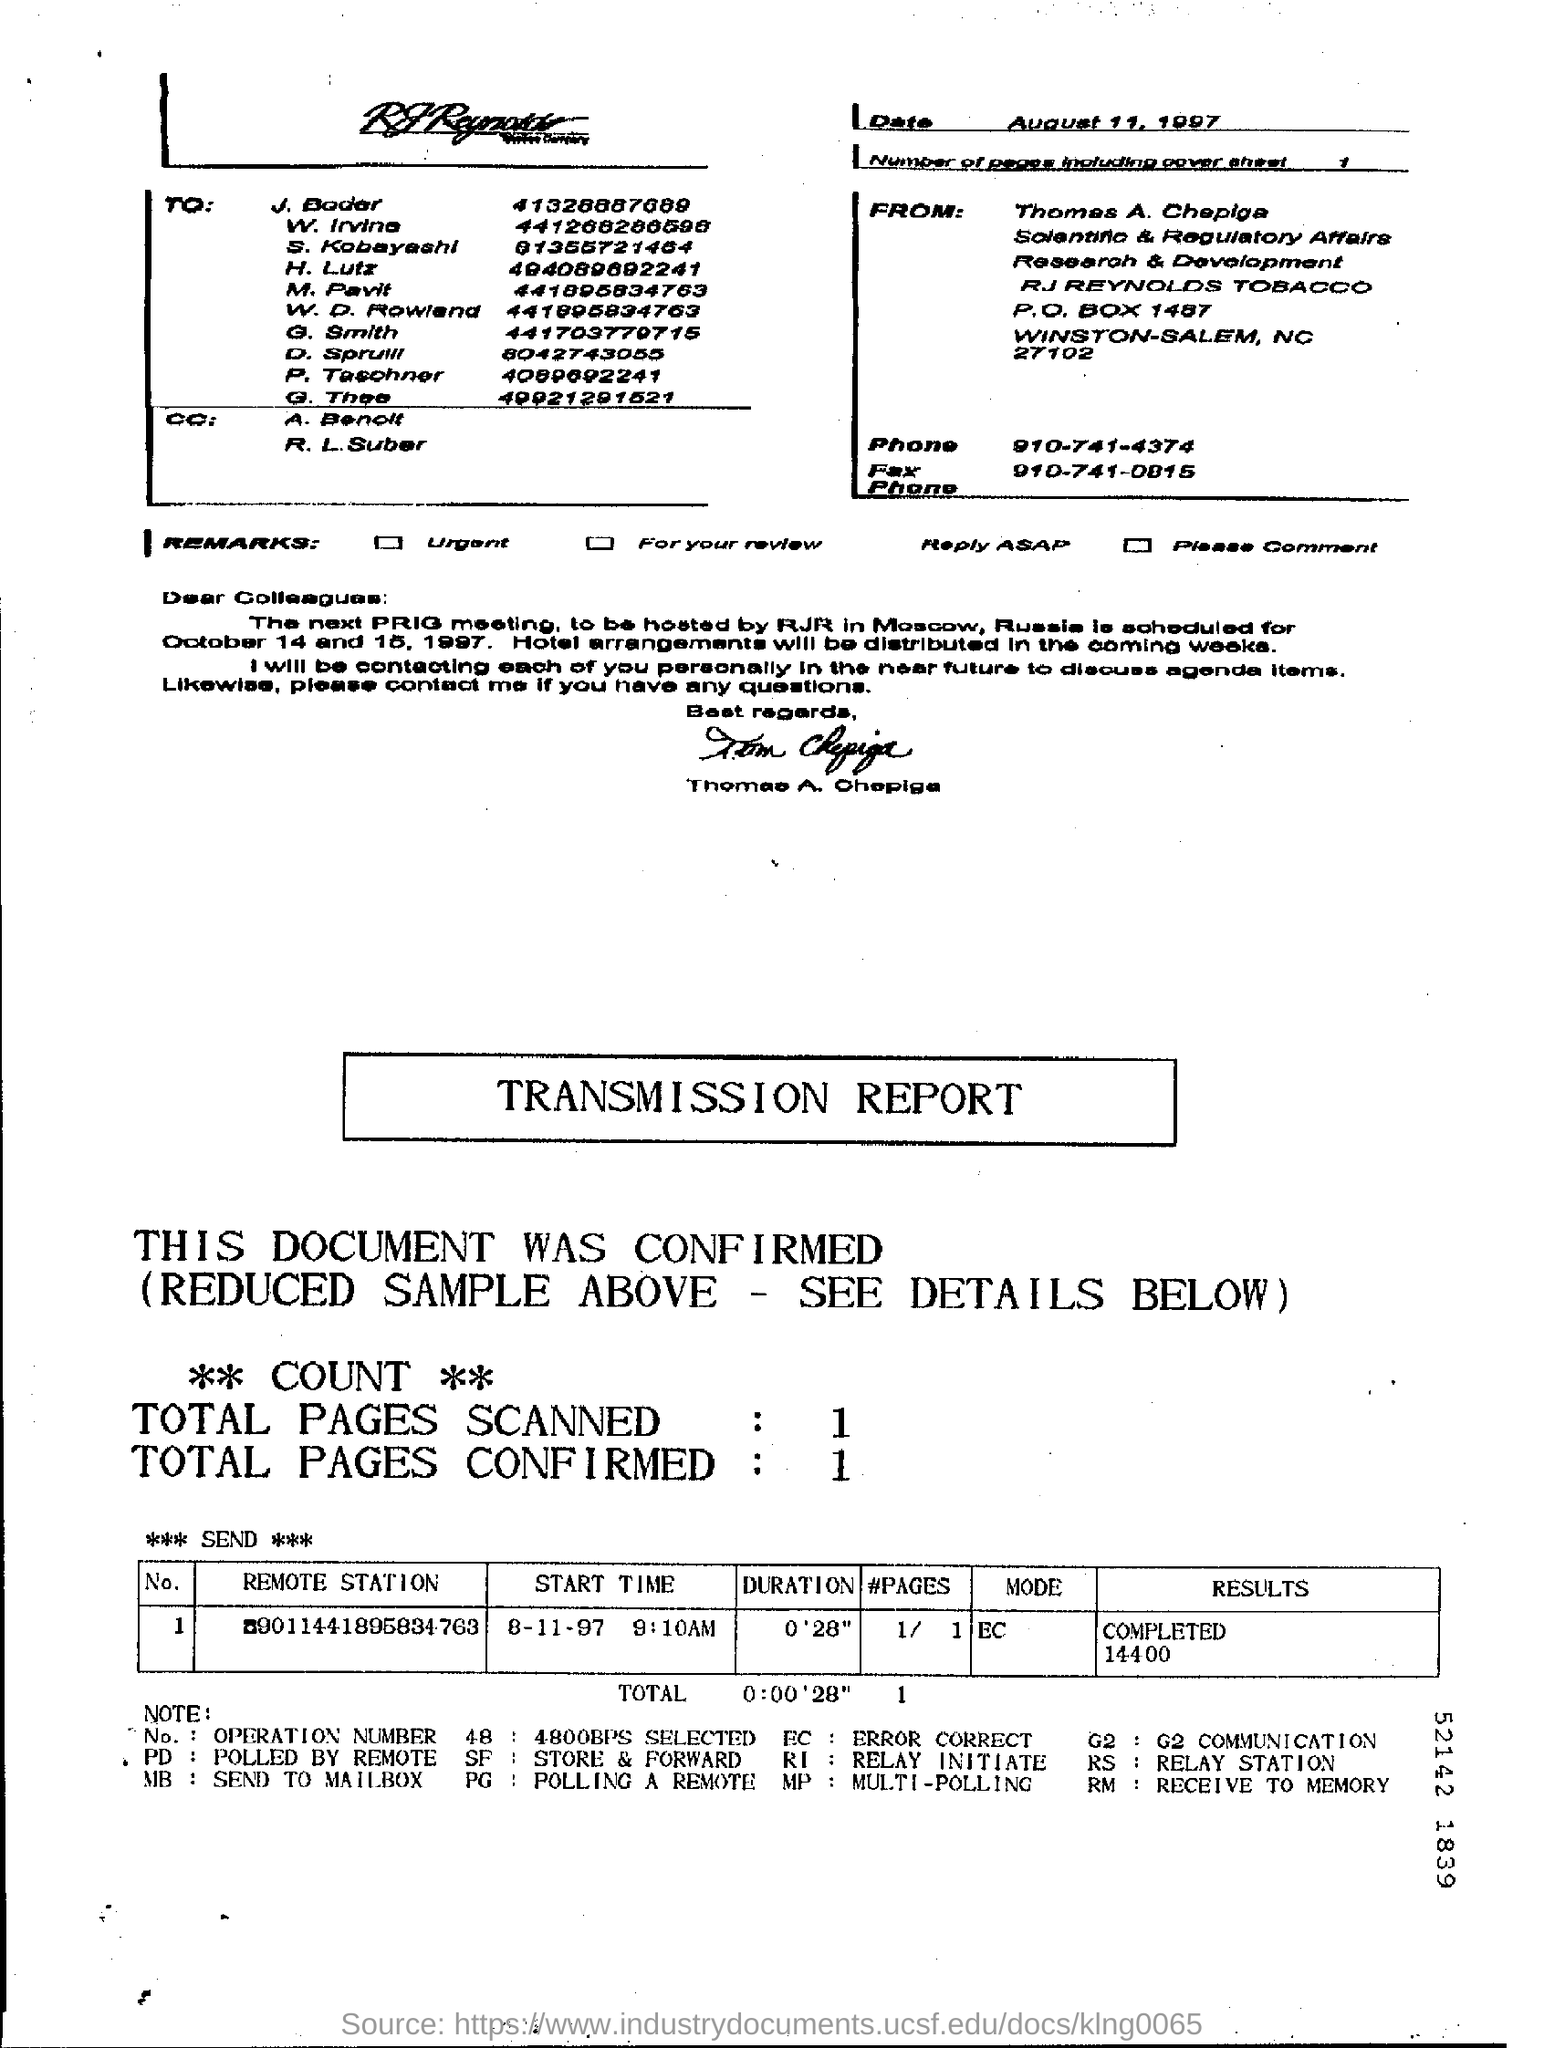How many pages are there including cover sheet ?
Your answer should be very brief. 1. What is the phone number given in the page ?
Provide a short and direct response. 910-741-4374. What is the fax number mentioned in the given letter ?
Ensure brevity in your answer.  910-741-0815. How many total pages are scanned in the report ?
Your answer should be compact. 1. How many total pages are confirmed in the report ?
Provide a succinct answer. 1. What is the duration mentioned in the report ?
Make the answer very short. 0'28". 